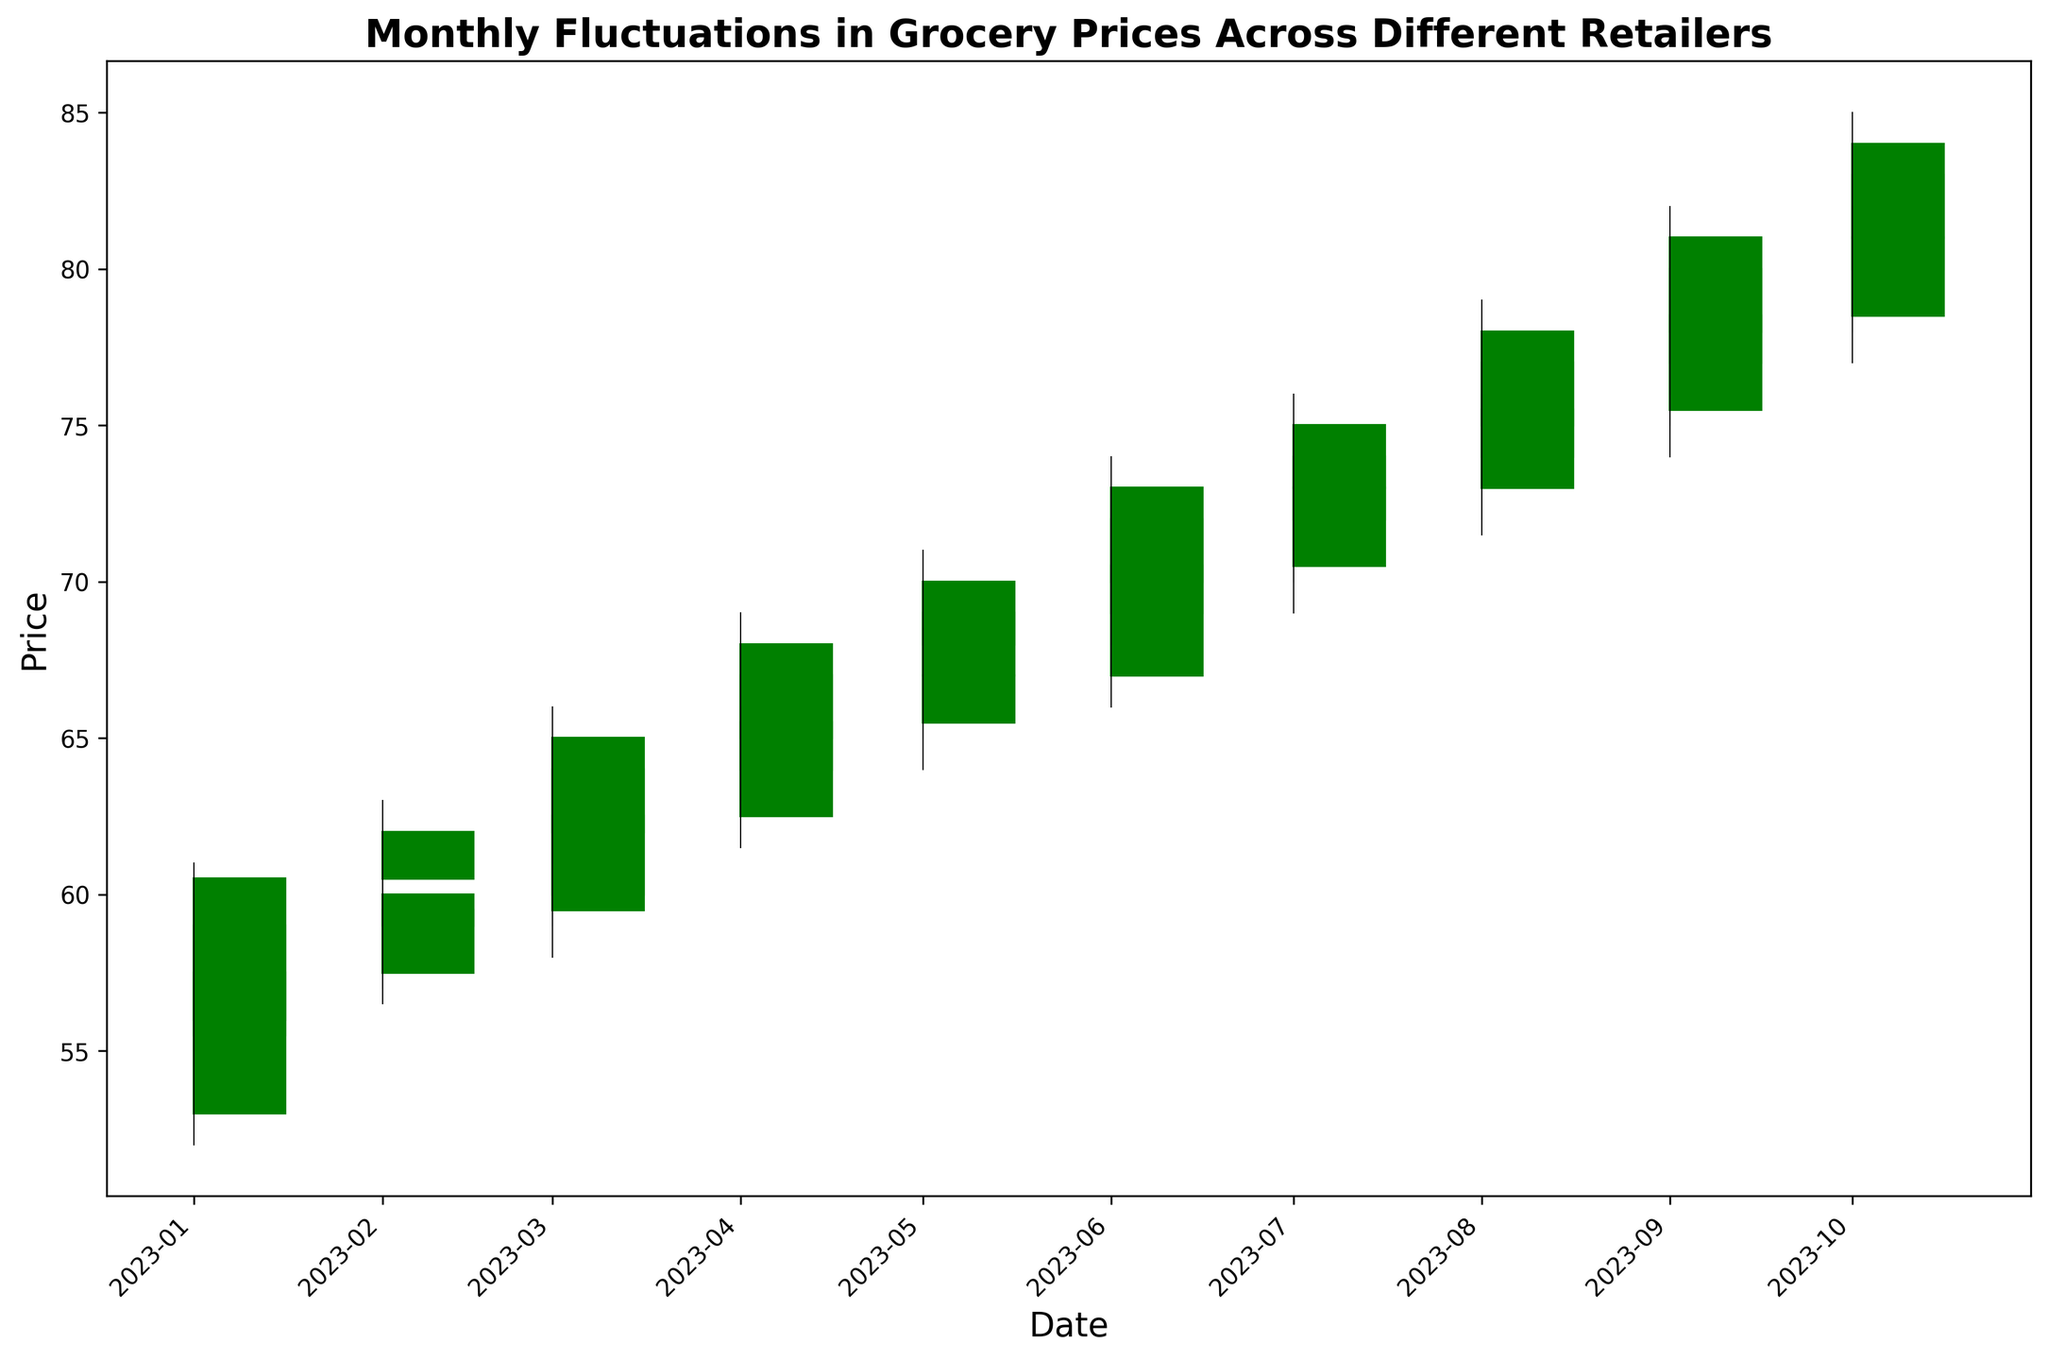When did StoreA reach its highest monthly closing price, and what was the price? To find this, look at the plot for the highest closing point for StoreA, represented by the tallest green rectangle for StoreA. This occurs in October 2023 with a closing price of 83.0.
Answer: October 2023, 83.0 Which retailer had the smallest range of prices in January 2023? To determine this, you need to find the difference between the highest and lowest prices for each retailer in January 2023. StoreC had the smallest range (58.5 - 52.0) which is 6.5.
Answer: StoreC Between February and March 2023, which retailer had the largest increase in the closing price? Calculate the difference in closing prices between February and March for each retailer. StoreA's increase is 64.0 - 60.0 = 4.0, StoreB's increase is 65.0 - 62.0 = 3.0, and StoreC's increase is 62.5 - 59.5 = 3.0. StoreA had the largest increase in closing price by 4.0.
Answer: StoreA Which month and retailer had a closing price decrease from the opening price despite having a high that was significantly higher than the opening price? To find this, look for red rectangles (indicating a closing price lower than the opening price) where the highest price (top of the line) is significantly higher than the opening price. In February StoreC, March StoreC and August StoreC fulfill this criterion.
Answer: February StoreC, March StoreC and August StoreC In which month did StoreB experience its largest range of prices, and what was the range? To find this, compare the range (highest price - lowest price) of StoreB for each month. StoreB had its highest range in October 2023 with 85.0 - 79.0 = 6.0.
Answer: October 2023, 6.0 From January to October 2023, how many times did StoreC close higher than StoreA? Find the instances when StoreC's closing price was higher than StoreA's. This occurs in January 2023 (57.5 vs 59.0). It happened just in January 2023, so the count is 1.
Answer: 1 What is the average high price for StoreA from January to October 2023? Add up the highest prices of StoreA for each month from January to October, then divide by the number of months (10): (60.0 + 62.0 + 65.0 + 68.0 + 70.0 + 73.0 + 75.0 + 78.0 + 81.0 + 84.0) / 10 = 71.6
Answer: 71.6 